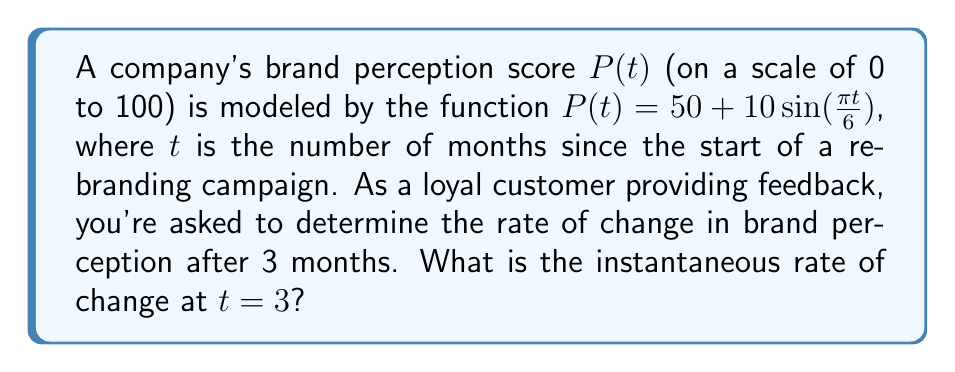Give your solution to this math problem. To find the instantaneous rate of change at $t=3$, we need to calculate the derivative of $P(t)$ and then evaluate it at $t=3$.

Step 1: Find the derivative of $P(t)$
$$\frac{d}{dt}P(t) = \frac{d}{dt}[50 + 10\sin(\frac{\pi t}{6})]$$
$$P'(t) = 10 \cdot \frac{\pi}{6} \cos(\frac{\pi t}{6})$$
$$P'(t) = \frac{5\pi}{3} \cos(\frac{\pi t}{6})$$

Step 2: Evaluate $P'(t)$ at $t=3$
$$P'(3) = \frac{5\pi}{3} \cos(\frac{\pi \cdot 3}{6})$$
$$P'(3) = \frac{5\pi}{3} \cos(\frac{\pi}{2})$$

Step 3: Simplify
Since $\cos(\frac{\pi}{2}) = 0$, we have:
$$P'(3) = \frac{5\pi}{3} \cdot 0 = 0$$

Therefore, the instantaneous rate of change in brand perception after 3 months is 0 points per month.
Answer: 0 points/month 